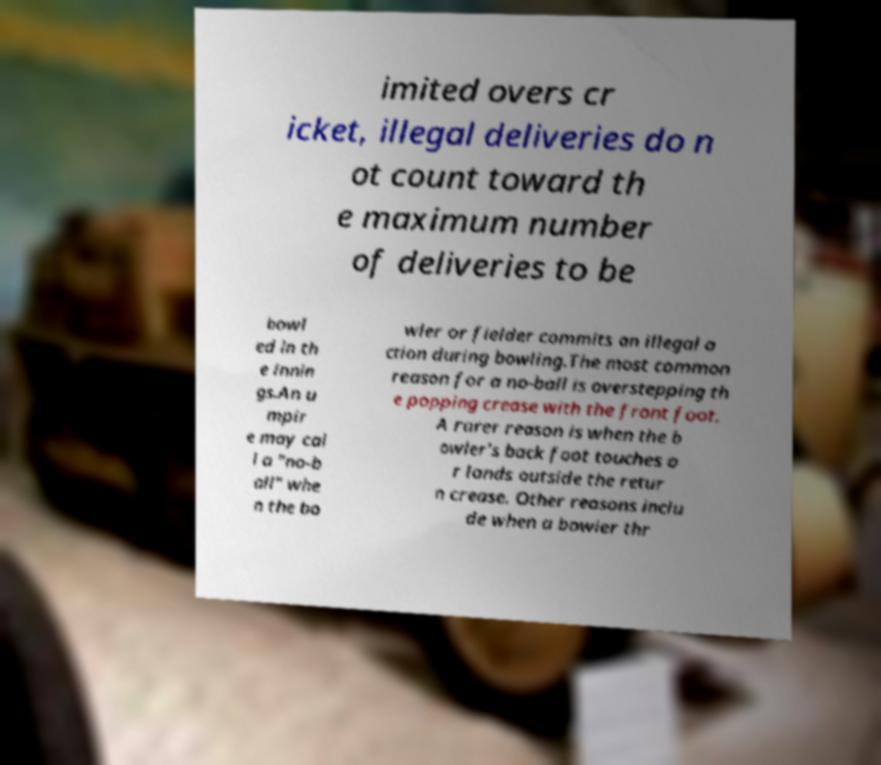There's text embedded in this image that I need extracted. Can you transcribe it verbatim? imited overs cr icket, illegal deliveries do n ot count toward th e maximum number of deliveries to be bowl ed in th e innin gs.An u mpir e may cal l a "no-b all" whe n the bo wler or fielder commits an illegal a ction during bowling.The most common reason for a no-ball is overstepping th e popping crease with the front foot. A rarer reason is when the b owler's back foot touches o r lands outside the retur n crease. Other reasons inclu de when a bowler thr 